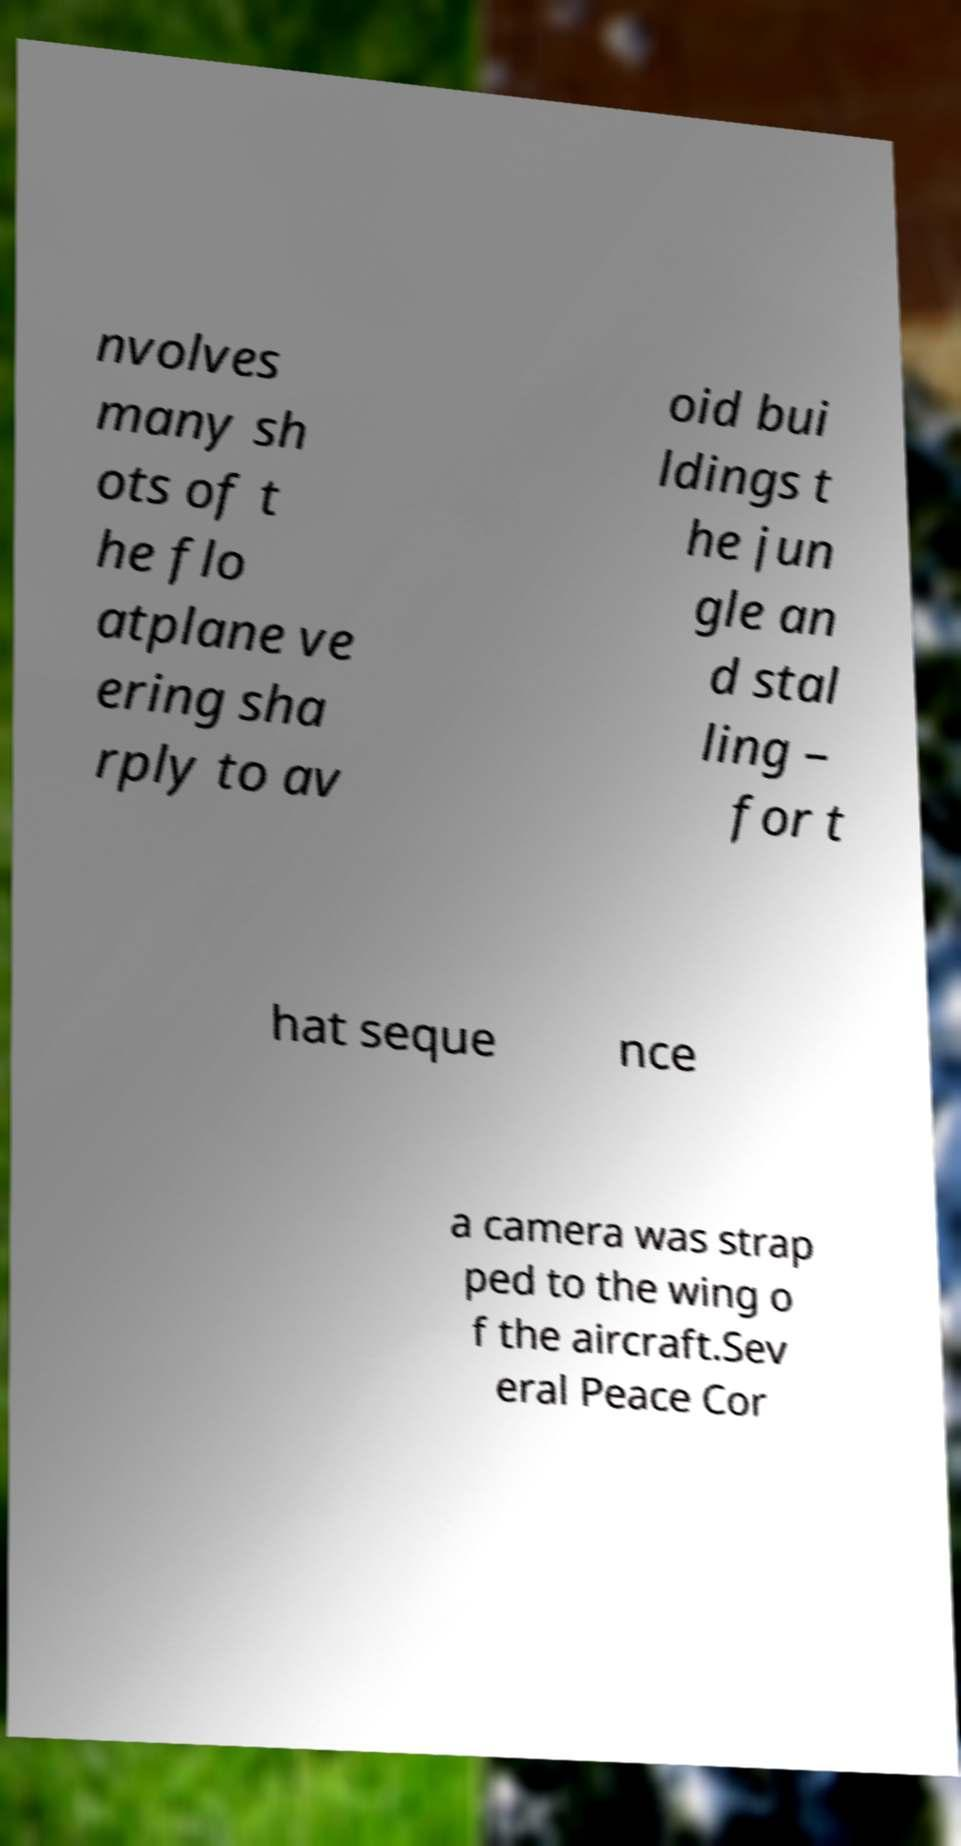Can you accurately transcribe the text from the provided image for me? nvolves many sh ots of t he flo atplane ve ering sha rply to av oid bui ldings t he jun gle an d stal ling – for t hat seque nce a camera was strap ped to the wing o f the aircraft.Sev eral Peace Cor 